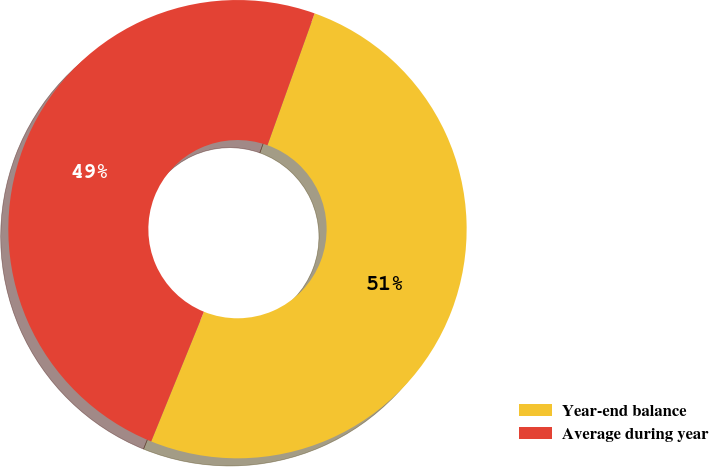Convert chart. <chart><loc_0><loc_0><loc_500><loc_500><pie_chart><fcel>Year-end balance<fcel>Average during year<nl><fcel>50.68%<fcel>49.32%<nl></chart> 